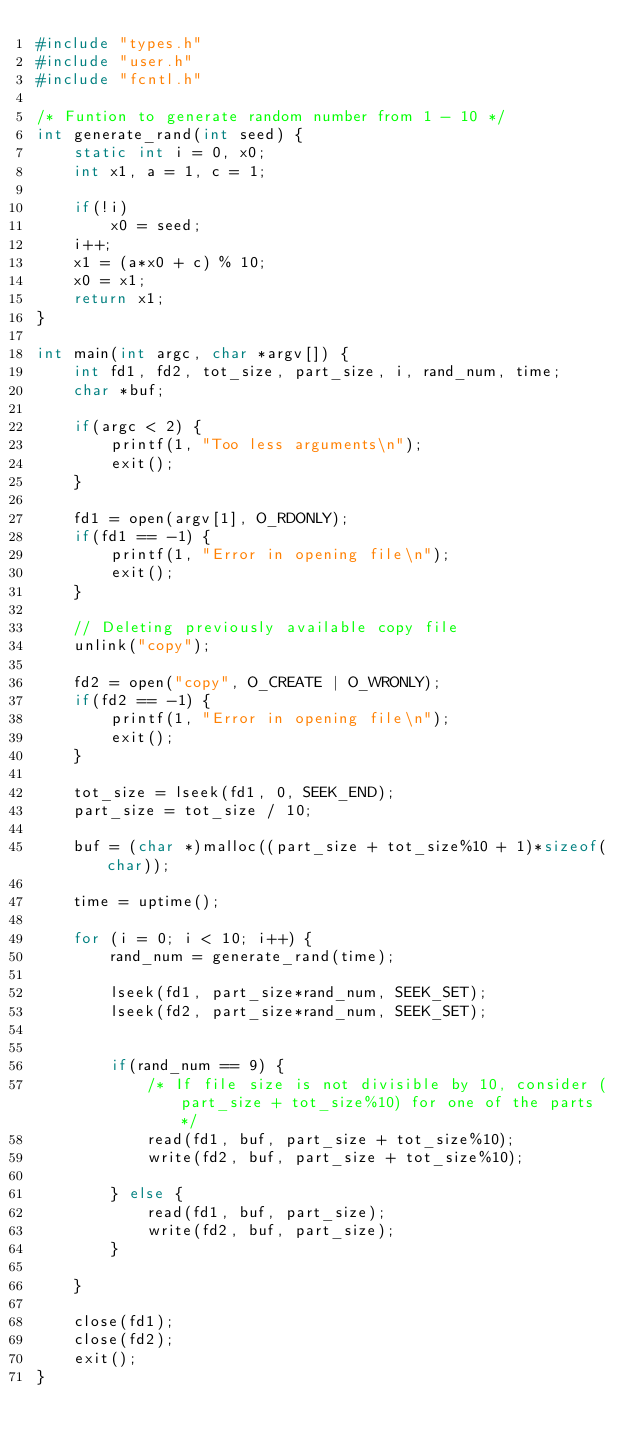Convert code to text. <code><loc_0><loc_0><loc_500><loc_500><_C_>#include "types.h"
#include "user.h"
#include "fcntl.h"

/* Funtion to generate random number from 1 - 10 */
int generate_rand(int seed) {
	static int i = 0, x0;
	int x1, a = 1, c = 1;

	if(!i)
		x0 = seed;
	i++;
	x1 = (a*x0 + c) % 10;
	x0 = x1;
	return x1;
}

int main(int argc, char *argv[]) {
	int fd1, fd2, tot_size, part_size, i, rand_num, time;
	char *buf;

	if(argc < 2) {
		printf(1, "Too less arguments\n");
		exit();
	}

	fd1 = open(argv[1], O_RDONLY);
	if(fd1 == -1) {
		printf(1, "Error in opening file\n");
		exit();
	}

	// Deleting previously available copy file
	unlink("copy");

	fd2 = open("copy", O_CREATE | O_WRONLY);
	if(fd2 == -1) {
		printf(1, "Error in opening file\n");
		exit();
	}

	tot_size = lseek(fd1, 0, SEEK_END);
	part_size = tot_size / 10;

	buf = (char *)malloc((part_size + tot_size%10 + 1)*sizeof(char));

	time = uptime();

	for (i = 0; i < 10; i++) {
		rand_num = generate_rand(time);

		lseek(fd1, part_size*rand_num, SEEK_SET);
		lseek(fd2, part_size*rand_num, SEEK_SET);
		

		if(rand_num == 9) {
			/* If file size is not divisible by 10, consider (part_size + tot_size%10) for one of the parts*/
			read(fd1, buf, part_size + tot_size%10);
			write(fd2, buf, part_size + tot_size%10);

		} else {
			read(fd1, buf, part_size);
			write(fd2, buf, part_size);
		}
		
	}

	close(fd1);
	close(fd2);
	exit();
}</code> 